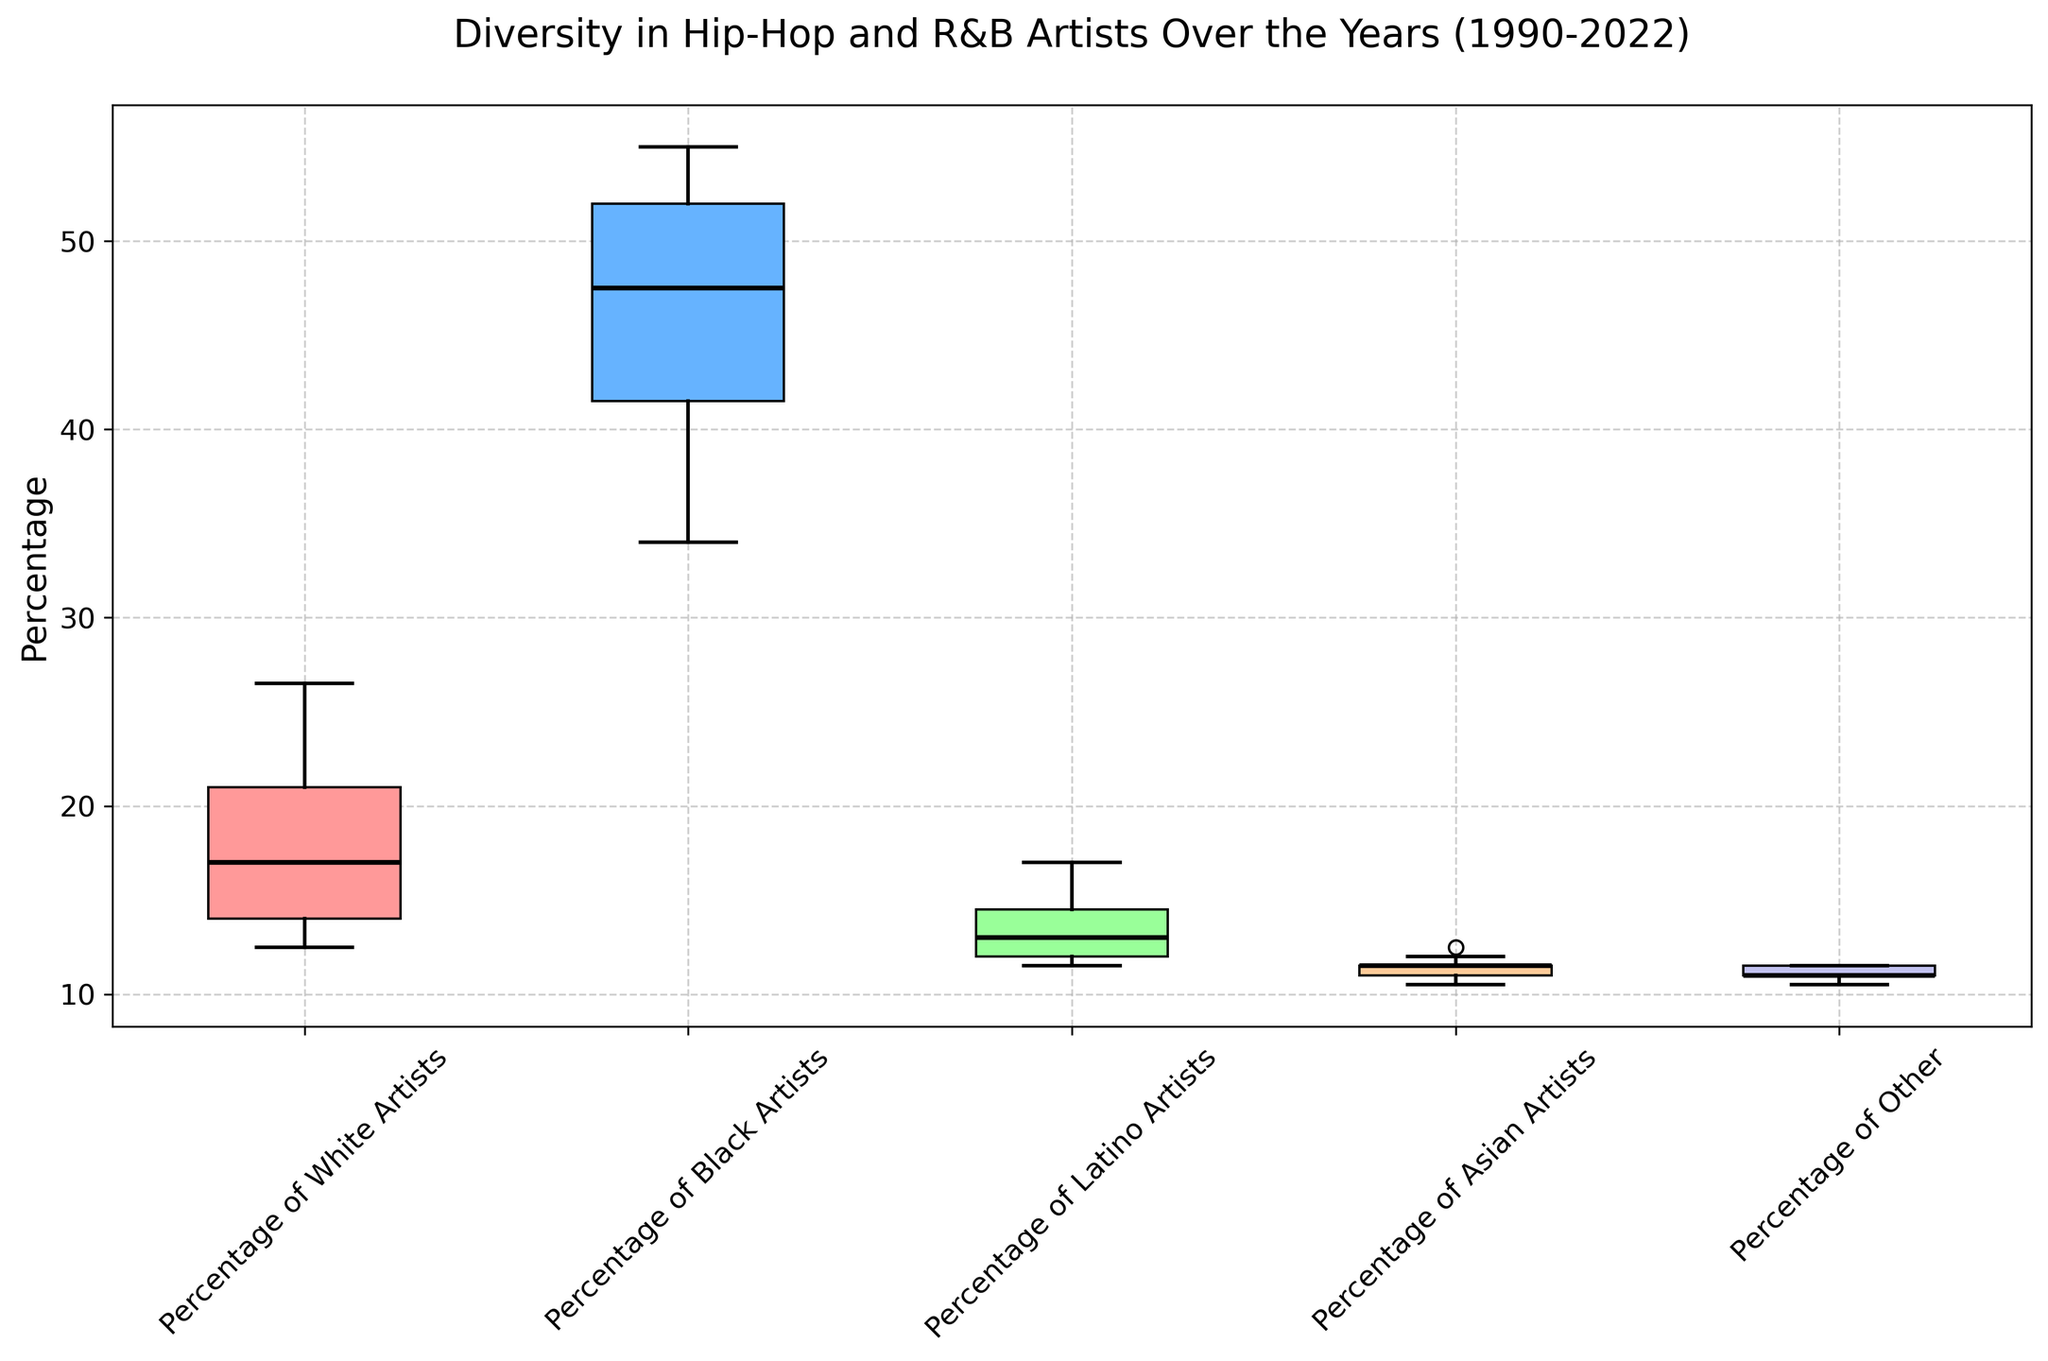What is the median percentage of Black artists across the years? To find the median percentage of Black artists across the years, look at the black line within the box for Black artists. The median line is around 75%.
Answer: 75% What percentage difference is there between the highest and lowest percentages of White artists? Identify the maximum and minimum points on the box plot for White artists. The highest point is 33%, and the lowest point is 5%. The difference is 33% - 5% = 28%.
Answer: 28% Which group has the lowest variability in artist percentages over the years? Look for the box plot with the shortest height since shorter boxes indicate less variability. The Asian artists have the shortest box plot.
Answer: Asian artists Between Latino and Asian artists, which group shows a greater median percentage? Compare the median lines (black lines in each box) for both Latino and Asian artists. The median line for Latino artists is higher than that for Asian artists.
Answer: Latino artists What is the range of percentages for Other artists? Determine the lowest and highest values within the whiskers for Other artists. The range is from 1% to 5%. So, 5% - 1% = 4%.
Answer: 4% Which group saw the highest increase in percentages over the years? To determine this, compare the ends of the whiskers for each group. White artists show the highest increase from 5% to 33%.
Answer: White artists What is the interquartile range (IQR) for Black artists? The IQR is the difference between the third quartile (Q3) and the first quartile (Q1). For Black artists, Q3 is about 87% and Q1 is about 61%. So, the IQR is 87% - 61% = 26%.
Answer: 26% How does the median percentage of Latino artists compare to that of Other artists? Look at the middle lines in the boxes for Latino and Other artists. The median for Latino artists is around 8%, and for Other artists, it is around 2%. The Latino median is higher.
Answer: Latino artists have a higher median What is the maximum percentage reached by Black artists over the years? Look at the maximum point of the whisker for Black artists, which is about 90%.
Answer: 90% Which group has the second highest median percentage? First, identify the group with the absolute highest median, which is Black artists. The second highest median is for White artists.
Answer: White artists 